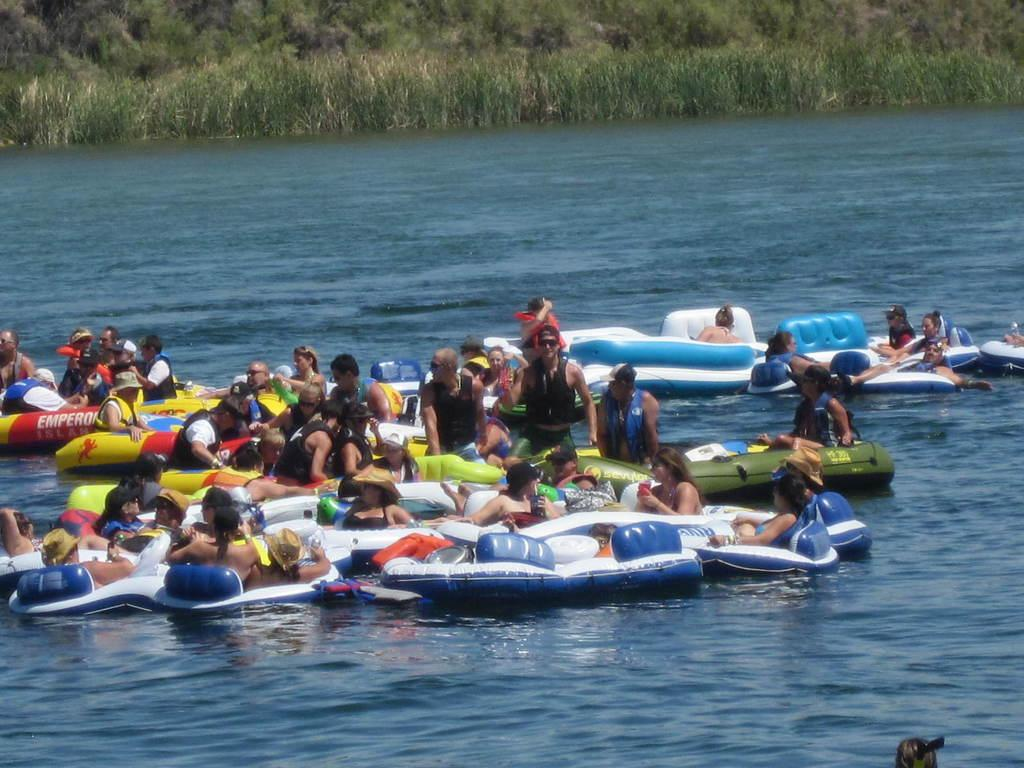What is happening on the water in the image? There are boats on the water in the image. Who is in the boats? There are people in the boats. What can be seen in the background of the image? There are trees visible in the background of the image. What type of ball is being used for pleasure on the boats in the image? There is no ball present in the image; it features boats with people on the water. How many feet of water are visible in the image? The depth of the water cannot be determined from the image, as it only shows the surface of the water. 